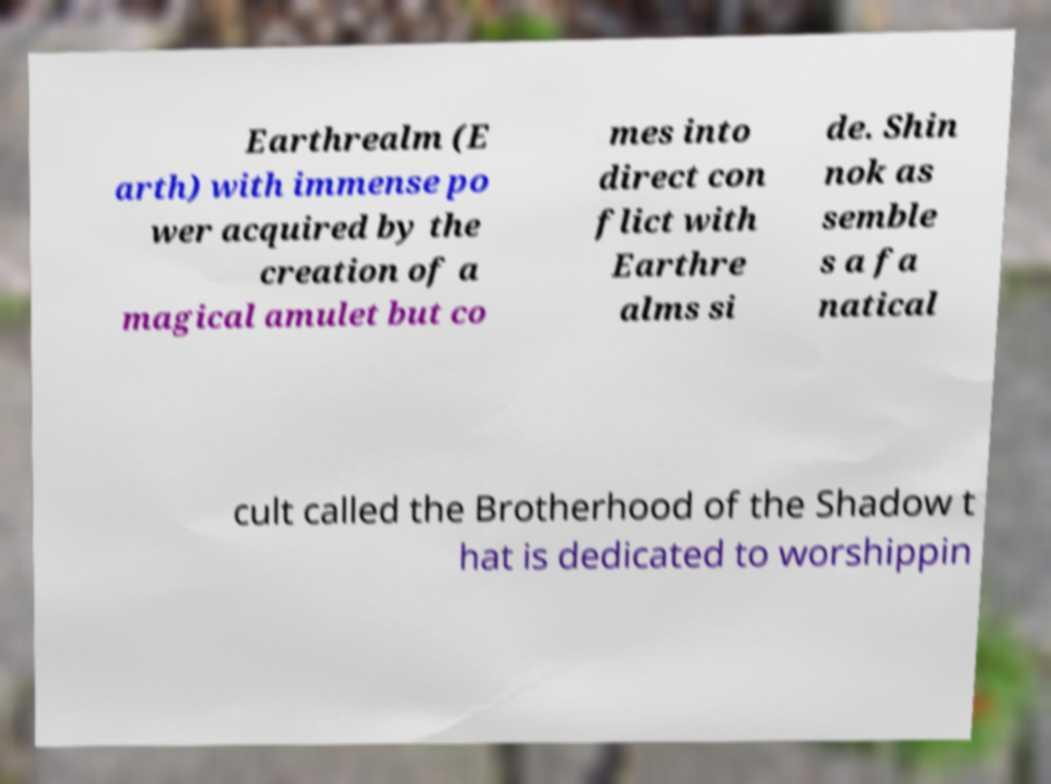Can you read and provide the text displayed in the image?This photo seems to have some interesting text. Can you extract and type it out for me? Earthrealm (E arth) with immense po wer acquired by the creation of a magical amulet but co mes into direct con flict with Earthre alms si de. Shin nok as semble s a fa natical cult called the Brotherhood of the Shadow t hat is dedicated to worshippin 